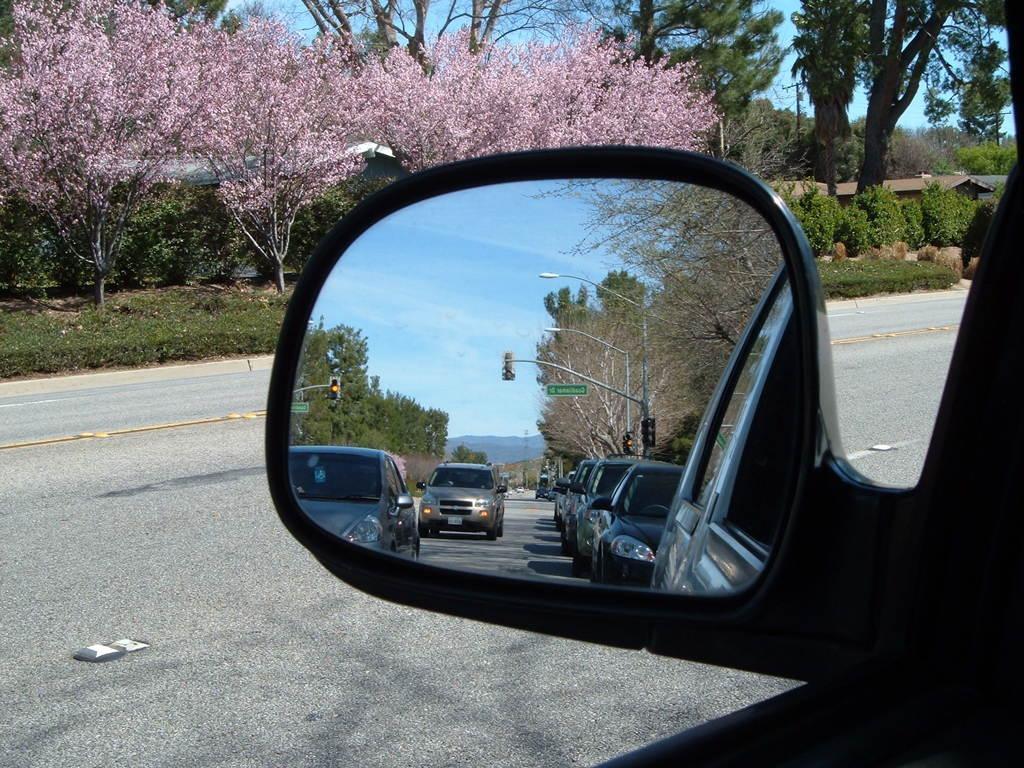Describe this image in one or two sentences. In this picture we can see a vehicle´s mirror here, we can see reflection of cars, poles, lights, trees and sky in this mirror, in the background there are some trees and plants here. 